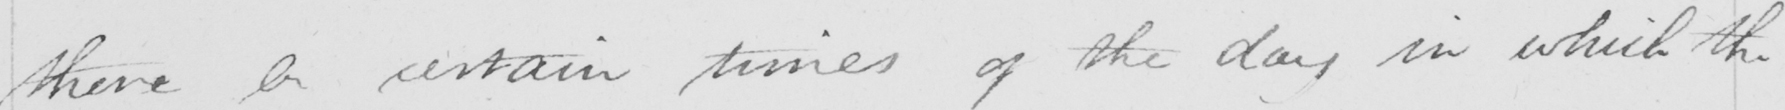Can you tell me what this handwritten text says? there be certain times of the day in which the 